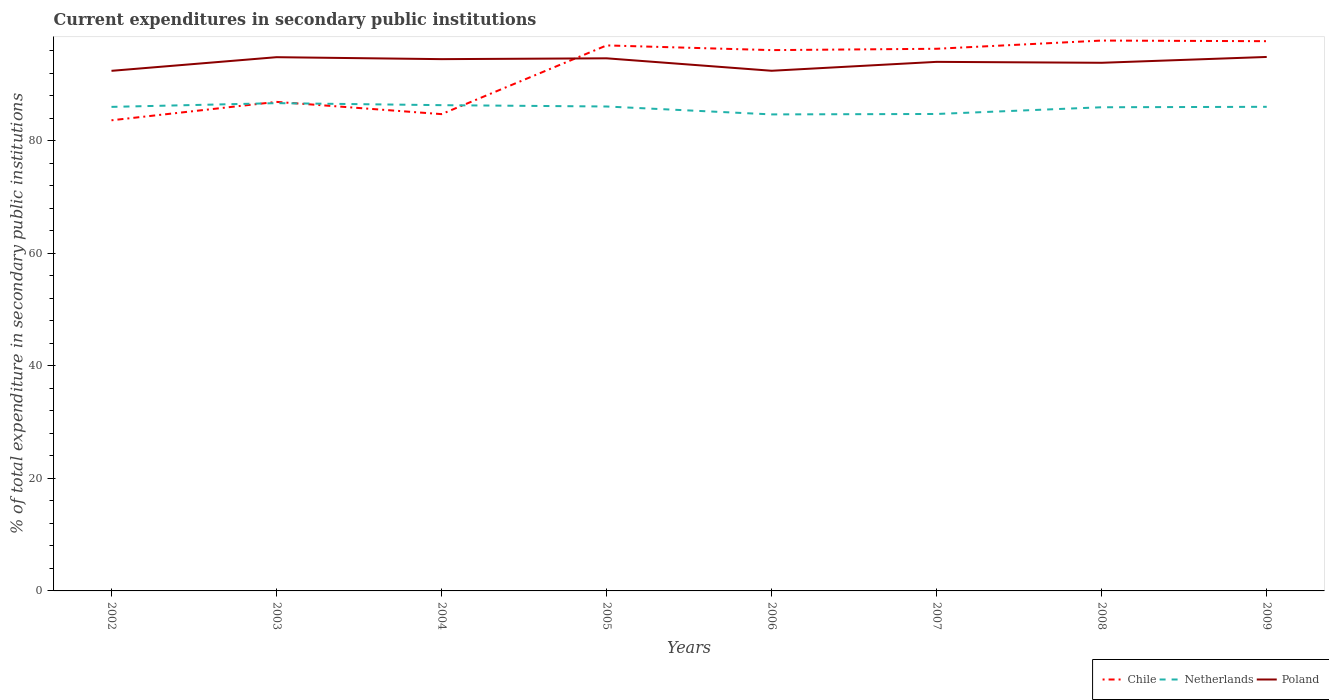Does the line corresponding to Poland intersect with the line corresponding to Chile?
Your response must be concise. Yes. Is the number of lines equal to the number of legend labels?
Your answer should be very brief. Yes. Across all years, what is the maximum current expenditures in secondary public institutions in Poland?
Provide a succinct answer. 92.39. In which year was the current expenditures in secondary public institutions in Poland maximum?
Provide a succinct answer. 2002. What is the total current expenditures in secondary public institutions in Netherlands in the graph?
Your answer should be very brief. -0.08. What is the difference between the highest and the second highest current expenditures in secondary public institutions in Chile?
Offer a terse response. 14.16. How many lines are there?
Offer a very short reply. 3. How many years are there in the graph?
Make the answer very short. 8. What is the difference between two consecutive major ticks on the Y-axis?
Your response must be concise. 20. Does the graph contain any zero values?
Keep it short and to the point. No. Does the graph contain grids?
Keep it short and to the point. No. Where does the legend appear in the graph?
Offer a terse response. Bottom right. How many legend labels are there?
Provide a short and direct response. 3. How are the legend labels stacked?
Ensure brevity in your answer.  Horizontal. What is the title of the graph?
Ensure brevity in your answer.  Current expenditures in secondary public institutions. What is the label or title of the X-axis?
Your answer should be compact. Years. What is the label or title of the Y-axis?
Make the answer very short. % of total expenditure in secondary public institutions. What is the % of total expenditure in secondary public institutions in Chile in 2002?
Ensure brevity in your answer.  83.6. What is the % of total expenditure in secondary public institutions in Netherlands in 2002?
Offer a terse response. 85.98. What is the % of total expenditure in secondary public institutions of Poland in 2002?
Offer a very short reply. 92.39. What is the % of total expenditure in secondary public institutions in Chile in 2003?
Provide a succinct answer. 86.87. What is the % of total expenditure in secondary public institutions of Netherlands in 2003?
Give a very brief answer. 86.65. What is the % of total expenditure in secondary public institutions of Poland in 2003?
Give a very brief answer. 94.81. What is the % of total expenditure in secondary public institutions in Chile in 2004?
Offer a terse response. 84.69. What is the % of total expenditure in secondary public institutions in Netherlands in 2004?
Your answer should be compact. 86.29. What is the % of total expenditure in secondary public institutions in Poland in 2004?
Give a very brief answer. 94.46. What is the % of total expenditure in secondary public institutions of Chile in 2005?
Your response must be concise. 96.9. What is the % of total expenditure in secondary public institutions in Netherlands in 2005?
Provide a succinct answer. 86.05. What is the % of total expenditure in secondary public institutions in Poland in 2005?
Give a very brief answer. 94.61. What is the % of total expenditure in secondary public institutions of Chile in 2006?
Make the answer very short. 96.07. What is the % of total expenditure in secondary public institutions in Netherlands in 2006?
Your response must be concise. 84.65. What is the % of total expenditure in secondary public institutions in Poland in 2006?
Your response must be concise. 92.4. What is the % of total expenditure in secondary public institutions in Chile in 2007?
Offer a very short reply. 96.31. What is the % of total expenditure in secondary public institutions of Netherlands in 2007?
Keep it short and to the point. 84.72. What is the % of total expenditure in secondary public institutions in Poland in 2007?
Your answer should be compact. 93.98. What is the % of total expenditure in secondary public institutions of Chile in 2008?
Ensure brevity in your answer.  97.76. What is the % of total expenditure in secondary public institutions of Netherlands in 2008?
Keep it short and to the point. 85.92. What is the % of total expenditure in secondary public institutions in Poland in 2008?
Make the answer very short. 93.82. What is the % of total expenditure in secondary public institutions in Chile in 2009?
Provide a succinct answer. 97.65. What is the % of total expenditure in secondary public institutions of Netherlands in 2009?
Offer a terse response. 86. What is the % of total expenditure in secondary public institutions of Poland in 2009?
Keep it short and to the point. 94.85. Across all years, what is the maximum % of total expenditure in secondary public institutions in Chile?
Give a very brief answer. 97.76. Across all years, what is the maximum % of total expenditure in secondary public institutions of Netherlands?
Offer a terse response. 86.65. Across all years, what is the maximum % of total expenditure in secondary public institutions of Poland?
Your response must be concise. 94.85. Across all years, what is the minimum % of total expenditure in secondary public institutions in Chile?
Make the answer very short. 83.6. Across all years, what is the minimum % of total expenditure in secondary public institutions of Netherlands?
Keep it short and to the point. 84.65. Across all years, what is the minimum % of total expenditure in secondary public institutions in Poland?
Your answer should be very brief. 92.39. What is the total % of total expenditure in secondary public institutions in Chile in the graph?
Your response must be concise. 739.85. What is the total % of total expenditure in secondary public institutions of Netherlands in the graph?
Offer a terse response. 686.24. What is the total % of total expenditure in secondary public institutions of Poland in the graph?
Give a very brief answer. 751.31. What is the difference between the % of total expenditure in secondary public institutions of Chile in 2002 and that in 2003?
Your response must be concise. -3.27. What is the difference between the % of total expenditure in secondary public institutions of Netherlands in 2002 and that in 2003?
Keep it short and to the point. -0.66. What is the difference between the % of total expenditure in secondary public institutions of Poland in 2002 and that in 2003?
Your response must be concise. -2.42. What is the difference between the % of total expenditure in secondary public institutions of Chile in 2002 and that in 2004?
Your answer should be compact. -1.09. What is the difference between the % of total expenditure in secondary public institutions of Netherlands in 2002 and that in 2004?
Give a very brief answer. -0.31. What is the difference between the % of total expenditure in secondary public institutions of Poland in 2002 and that in 2004?
Give a very brief answer. -2.08. What is the difference between the % of total expenditure in secondary public institutions of Chile in 2002 and that in 2005?
Provide a succinct answer. -13.3. What is the difference between the % of total expenditure in secondary public institutions in Netherlands in 2002 and that in 2005?
Offer a very short reply. -0.07. What is the difference between the % of total expenditure in secondary public institutions of Poland in 2002 and that in 2005?
Provide a succinct answer. -2.22. What is the difference between the % of total expenditure in secondary public institutions of Chile in 2002 and that in 2006?
Provide a succinct answer. -12.46. What is the difference between the % of total expenditure in secondary public institutions of Netherlands in 2002 and that in 2006?
Offer a very short reply. 1.34. What is the difference between the % of total expenditure in secondary public institutions of Poland in 2002 and that in 2006?
Offer a very short reply. -0.01. What is the difference between the % of total expenditure in secondary public institutions of Chile in 2002 and that in 2007?
Make the answer very short. -12.7. What is the difference between the % of total expenditure in secondary public institutions in Netherlands in 2002 and that in 2007?
Your response must be concise. 1.26. What is the difference between the % of total expenditure in secondary public institutions of Poland in 2002 and that in 2007?
Provide a succinct answer. -1.59. What is the difference between the % of total expenditure in secondary public institutions of Chile in 2002 and that in 2008?
Provide a succinct answer. -14.16. What is the difference between the % of total expenditure in secondary public institutions in Netherlands in 2002 and that in 2008?
Give a very brief answer. 0.07. What is the difference between the % of total expenditure in secondary public institutions in Poland in 2002 and that in 2008?
Provide a succinct answer. -1.43. What is the difference between the % of total expenditure in secondary public institutions of Chile in 2002 and that in 2009?
Your response must be concise. -14.05. What is the difference between the % of total expenditure in secondary public institutions of Netherlands in 2002 and that in 2009?
Offer a very short reply. -0.01. What is the difference between the % of total expenditure in secondary public institutions in Poland in 2002 and that in 2009?
Provide a succinct answer. -2.46. What is the difference between the % of total expenditure in secondary public institutions in Chile in 2003 and that in 2004?
Your answer should be compact. 2.17. What is the difference between the % of total expenditure in secondary public institutions in Netherlands in 2003 and that in 2004?
Keep it short and to the point. 0.36. What is the difference between the % of total expenditure in secondary public institutions in Poland in 2003 and that in 2004?
Make the answer very short. 0.35. What is the difference between the % of total expenditure in secondary public institutions in Chile in 2003 and that in 2005?
Make the answer very short. -10.03. What is the difference between the % of total expenditure in secondary public institutions in Netherlands in 2003 and that in 2005?
Your response must be concise. 0.6. What is the difference between the % of total expenditure in secondary public institutions in Poland in 2003 and that in 2005?
Offer a terse response. 0.2. What is the difference between the % of total expenditure in secondary public institutions in Chile in 2003 and that in 2006?
Offer a very short reply. -9.2. What is the difference between the % of total expenditure in secondary public institutions of Netherlands in 2003 and that in 2006?
Provide a succinct answer. 2. What is the difference between the % of total expenditure in secondary public institutions in Poland in 2003 and that in 2006?
Keep it short and to the point. 2.41. What is the difference between the % of total expenditure in secondary public institutions of Chile in 2003 and that in 2007?
Keep it short and to the point. -9.44. What is the difference between the % of total expenditure in secondary public institutions of Netherlands in 2003 and that in 2007?
Ensure brevity in your answer.  1.92. What is the difference between the % of total expenditure in secondary public institutions of Poland in 2003 and that in 2007?
Provide a short and direct response. 0.83. What is the difference between the % of total expenditure in secondary public institutions of Chile in 2003 and that in 2008?
Keep it short and to the point. -10.89. What is the difference between the % of total expenditure in secondary public institutions of Netherlands in 2003 and that in 2008?
Give a very brief answer. 0.73. What is the difference between the % of total expenditure in secondary public institutions of Chile in 2003 and that in 2009?
Keep it short and to the point. -10.78. What is the difference between the % of total expenditure in secondary public institutions in Netherlands in 2003 and that in 2009?
Your response must be concise. 0.65. What is the difference between the % of total expenditure in secondary public institutions of Poland in 2003 and that in 2009?
Offer a very short reply. -0.04. What is the difference between the % of total expenditure in secondary public institutions of Chile in 2004 and that in 2005?
Keep it short and to the point. -12.21. What is the difference between the % of total expenditure in secondary public institutions of Netherlands in 2004 and that in 2005?
Provide a short and direct response. 0.24. What is the difference between the % of total expenditure in secondary public institutions in Poland in 2004 and that in 2005?
Your answer should be very brief. -0.15. What is the difference between the % of total expenditure in secondary public institutions in Chile in 2004 and that in 2006?
Offer a very short reply. -11.37. What is the difference between the % of total expenditure in secondary public institutions in Netherlands in 2004 and that in 2006?
Give a very brief answer. 1.64. What is the difference between the % of total expenditure in secondary public institutions in Poland in 2004 and that in 2006?
Make the answer very short. 2.07. What is the difference between the % of total expenditure in secondary public institutions of Chile in 2004 and that in 2007?
Offer a terse response. -11.61. What is the difference between the % of total expenditure in secondary public institutions in Netherlands in 2004 and that in 2007?
Provide a short and direct response. 1.57. What is the difference between the % of total expenditure in secondary public institutions in Poland in 2004 and that in 2007?
Your answer should be very brief. 0.48. What is the difference between the % of total expenditure in secondary public institutions of Chile in 2004 and that in 2008?
Your response must be concise. -13.07. What is the difference between the % of total expenditure in secondary public institutions in Netherlands in 2004 and that in 2008?
Your response must be concise. 0.37. What is the difference between the % of total expenditure in secondary public institutions in Poland in 2004 and that in 2008?
Make the answer very short. 0.65. What is the difference between the % of total expenditure in secondary public institutions in Chile in 2004 and that in 2009?
Offer a very short reply. -12.96. What is the difference between the % of total expenditure in secondary public institutions in Netherlands in 2004 and that in 2009?
Provide a short and direct response. 0.29. What is the difference between the % of total expenditure in secondary public institutions in Poland in 2004 and that in 2009?
Your answer should be very brief. -0.39. What is the difference between the % of total expenditure in secondary public institutions of Chile in 2005 and that in 2006?
Make the answer very short. 0.84. What is the difference between the % of total expenditure in secondary public institutions of Netherlands in 2005 and that in 2006?
Make the answer very short. 1.4. What is the difference between the % of total expenditure in secondary public institutions in Poland in 2005 and that in 2006?
Your answer should be compact. 2.21. What is the difference between the % of total expenditure in secondary public institutions of Chile in 2005 and that in 2007?
Make the answer very short. 0.6. What is the difference between the % of total expenditure in secondary public institutions in Netherlands in 2005 and that in 2007?
Your response must be concise. 1.33. What is the difference between the % of total expenditure in secondary public institutions of Poland in 2005 and that in 2007?
Make the answer very short. 0.63. What is the difference between the % of total expenditure in secondary public institutions of Chile in 2005 and that in 2008?
Ensure brevity in your answer.  -0.86. What is the difference between the % of total expenditure in secondary public institutions in Netherlands in 2005 and that in 2008?
Your answer should be compact. 0.13. What is the difference between the % of total expenditure in secondary public institutions of Poland in 2005 and that in 2008?
Give a very brief answer. 0.79. What is the difference between the % of total expenditure in secondary public institutions in Chile in 2005 and that in 2009?
Make the answer very short. -0.75. What is the difference between the % of total expenditure in secondary public institutions of Netherlands in 2005 and that in 2009?
Provide a succinct answer. 0.05. What is the difference between the % of total expenditure in secondary public institutions in Poland in 2005 and that in 2009?
Provide a succinct answer. -0.24. What is the difference between the % of total expenditure in secondary public institutions in Chile in 2006 and that in 2007?
Give a very brief answer. -0.24. What is the difference between the % of total expenditure in secondary public institutions in Netherlands in 2006 and that in 2007?
Ensure brevity in your answer.  -0.08. What is the difference between the % of total expenditure in secondary public institutions in Poland in 2006 and that in 2007?
Your answer should be very brief. -1.58. What is the difference between the % of total expenditure in secondary public institutions in Chile in 2006 and that in 2008?
Your answer should be very brief. -1.7. What is the difference between the % of total expenditure in secondary public institutions in Netherlands in 2006 and that in 2008?
Keep it short and to the point. -1.27. What is the difference between the % of total expenditure in secondary public institutions in Poland in 2006 and that in 2008?
Provide a short and direct response. -1.42. What is the difference between the % of total expenditure in secondary public institutions in Chile in 2006 and that in 2009?
Provide a short and direct response. -1.59. What is the difference between the % of total expenditure in secondary public institutions of Netherlands in 2006 and that in 2009?
Provide a succinct answer. -1.35. What is the difference between the % of total expenditure in secondary public institutions in Poland in 2006 and that in 2009?
Give a very brief answer. -2.45. What is the difference between the % of total expenditure in secondary public institutions of Chile in 2007 and that in 2008?
Offer a very short reply. -1.46. What is the difference between the % of total expenditure in secondary public institutions in Netherlands in 2007 and that in 2008?
Keep it short and to the point. -1.19. What is the difference between the % of total expenditure in secondary public institutions of Poland in 2007 and that in 2008?
Keep it short and to the point. 0.17. What is the difference between the % of total expenditure in secondary public institutions in Chile in 2007 and that in 2009?
Ensure brevity in your answer.  -1.35. What is the difference between the % of total expenditure in secondary public institutions of Netherlands in 2007 and that in 2009?
Your answer should be compact. -1.27. What is the difference between the % of total expenditure in secondary public institutions of Poland in 2007 and that in 2009?
Your answer should be compact. -0.87. What is the difference between the % of total expenditure in secondary public institutions in Chile in 2008 and that in 2009?
Offer a terse response. 0.11. What is the difference between the % of total expenditure in secondary public institutions in Netherlands in 2008 and that in 2009?
Make the answer very short. -0.08. What is the difference between the % of total expenditure in secondary public institutions of Poland in 2008 and that in 2009?
Provide a succinct answer. -1.04. What is the difference between the % of total expenditure in secondary public institutions in Chile in 2002 and the % of total expenditure in secondary public institutions in Netherlands in 2003?
Give a very brief answer. -3.05. What is the difference between the % of total expenditure in secondary public institutions in Chile in 2002 and the % of total expenditure in secondary public institutions in Poland in 2003?
Keep it short and to the point. -11.21. What is the difference between the % of total expenditure in secondary public institutions of Netherlands in 2002 and the % of total expenditure in secondary public institutions of Poland in 2003?
Offer a very short reply. -8.83. What is the difference between the % of total expenditure in secondary public institutions of Chile in 2002 and the % of total expenditure in secondary public institutions of Netherlands in 2004?
Give a very brief answer. -2.69. What is the difference between the % of total expenditure in secondary public institutions of Chile in 2002 and the % of total expenditure in secondary public institutions of Poland in 2004?
Make the answer very short. -10.86. What is the difference between the % of total expenditure in secondary public institutions of Netherlands in 2002 and the % of total expenditure in secondary public institutions of Poland in 2004?
Make the answer very short. -8.48. What is the difference between the % of total expenditure in secondary public institutions in Chile in 2002 and the % of total expenditure in secondary public institutions in Netherlands in 2005?
Your response must be concise. -2.45. What is the difference between the % of total expenditure in secondary public institutions in Chile in 2002 and the % of total expenditure in secondary public institutions in Poland in 2005?
Your answer should be very brief. -11.01. What is the difference between the % of total expenditure in secondary public institutions in Netherlands in 2002 and the % of total expenditure in secondary public institutions in Poland in 2005?
Your response must be concise. -8.63. What is the difference between the % of total expenditure in secondary public institutions of Chile in 2002 and the % of total expenditure in secondary public institutions of Netherlands in 2006?
Give a very brief answer. -1.04. What is the difference between the % of total expenditure in secondary public institutions of Chile in 2002 and the % of total expenditure in secondary public institutions of Poland in 2006?
Offer a very short reply. -8.8. What is the difference between the % of total expenditure in secondary public institutions of Netherlands in 2002 and the % of total expenditure in secondary public institutions of Poland in 2006?
Your response must be concise. -6.41. What is the difference between the % of total expenditure in secondary public institutions in Chile in 2002 and the % of total expenditure in secondary public institutions in Netherlands in 2007?
Provide a short and direct response. -1.12. What is the difference between the % of total expenditure in secondary public institutions in Chile in 2002 and the % of total expenditure in secondary public institutions in Poland in 2007?
Your response must be concise. -10.38. What is the difference between the % of total expenditure in secondary public institutions of Netherlands in 2002 and the % of total expenditure in secondary public institutions of Poland in 2007?
Offer a very short reply. -8. What is the difference between the % of total expenditure in secondary public institutions in Chile in 2002 and the % of total expenditure in secondary public institutions in Netherlands in 2008?
Provide a succinct answer. -2.31. What is the difference between the % of total expenditure in secondary public institutions of Chile in 2002 and the % of total expenditure in secondary public institutions of Poland in 2008?
Keep it short and to the point. -10.21. What is the difference between the % of total expenditure in secondary public institutions of Netherlands in 2002 and the % of total expenditure in secondary public institutions of Poland in 2008?
Ensure brevity in your answer.  -7.83. What is the difference between the % of total expenditure in secondary public institutions of Chile in 2002 and the % of total expenditure in secondary public institutions of Netherlands in 2009?
Your answer should be very brief. -2.39. What is the difference between the % of total expenditure in secondary public institutions in Chile in 2002 and the % of total expenditure in secondary public institutions in Poland in 2009?
Offer a terse response. -11.25. What is the difference between the % of total expenditure in secondary public institutions in Netherlands in 2002 and the % of total expenditure in secondary public institutions in Poland in 2009?
Provide a succinct answer. -8.87. What is the difference between the % of total expenditure in secondary public institutions in Chile in 2003 and the % of total expenditure in secondary public institutions in Netherlands in 2004?
Provide a short and direct response. 0.58. What is the difference between the % of total expenditure in secondary public institutions in Chile in 2003 and the % of total expenditure in secondary public institutions in Poland in 2004?
Keep it short and to the point. -7.59. What is the difference between the % of total expenditure in secondary public institutions of Netherlands in 2003 and the % of total expenditure in secondary public institutions of Poland in 2004?
Your response must be concise. -7.82. What is the difference between the % of total expenditure in secondary public institutions of Chile in 2003 and the % of total expenditure in secondary public institutions of Netherlands in 2005?
Your answer should be very brief. 0.82. What is the difference between the % of total expenditure in secondary public institutions in Chile in 2003 and the % of total expenditure in secondary public institutions in Poland in 2005?
Give a very brief answer. -7.74. What is the difference between the % of total expenditure in secondary public institutions of Netherlands in 2003 and the % of total expenditure in secondary public institutions of Poland in 2005?
Provide a succinct answer. -7.96. What is the difference between the % of total expenditure in secondary public institutions in Chile in 2003 and the % of total expenditure in secondary public institutions in Netherlands in 2006?
Your response must be concise. 2.22. What is the difference between the % of total expenditure in secondary public institutions in Chile in 2003 and the % of total expenditure in secondary public institutions in Poland in 2006?
Provide a succinct answer. -5.53. What is the difference between the % of total expenditure in secondary public institutions of Netherlands in 2003 and the % of total expenditure in secondary public institutions of Poland in 2006?
Ensure brevity in your answer.  -5.75. What is the difference between the % of total expenditure in secondary public institutions of Chile in 2003 and the % of total expenditure in secondary public institutions of Netherlands in 2007?
Your response must be concise. 2.15. What is the difference between the % of total expenditure in secondary public institutions of Chile in 2003 and the % of total expenditure in secondary public institutions of Poland in 2007?
Provide a succinct answer. -7.11. What is the difference between the % of total expenditure in secondary public institutions in Netherlands in 2003 and the % of total expenditure in secondary public institutions in Poland in 2007?
Offer a very short reply. -7.33. What is the difference between the % of total expenditure in secondary public institutions of Chile in 2003 and the % of total expenditure in secondary public institutions of Netherlands in 2008?
Give a very brief answer. 0.95. What is the difference between the % of total expenditure in secondary public institutions in Chile in 2003 and the % of total expenditure in secondary public institutions in Poland in 2008?
Ensure brevity in your answer.  -6.95. What is the difference between the % of total expenditure in secondary public institutions of Netherlands in 2003 and the % of total expenditure in secondary public institutions of Poland in 2008?
Ensure brevity in your answer.  -7.17. What is the difference between the % of total expenditure in secondary public institutions in Chile in 2003 and the % of total expenditure in secondary public institutions in Netherlands in 2009?
Offer a terse response. 0.87. What is the difference between the % of total expenditure in secondary public institutions of Chile in 2003 and the % of total expenditure in secondary public institutions of Poland in 2009?
Your response must be concise. -7.98. What is the difference between the % of total expenditure in secondary public institutions of Netherlands in 2003 and the % of total expenditure in secondary public institutions of Poland in 2009?
Provide a succinct answer. -8.2. What is the difference between the % of total expenditure in secondary public institutions of Chile in 2004 and the % of total expenditure in secondary public institutions of Netherlands in 2005?
Your response must be concise. -1.35. What is the difference between the % of total expenditure in secondary public institutions in Chile in 2004 and the % of total expenditure in secondary public institutions in Poland in 2005?
Your answer should be compact. -9.91. What is the difference between the % of total expenditure in secondary public institutions of Netherlands in 2004 and the % of total expenditure in secondary public institutions of Poland in 2005?
Give a very brief answer. -8.32. What is the difference between the % of total expenditure in secondary public institutions of Chile in 2004 and the % of total expenditure in secondary public institutions of Netherlands in 2006?
Offer a very short reply. 0.05. What is the difference between the % of total expenditure in secondary public institutions of Chile in 2004 and the % of total expenditure in secondary public institutions of Poland in 2006?
Offer a terse response. -7.7. What is the difference between the % of total expenditure in secondary public institutions in Netherlands in 2004 and the % of total expenditure in secondary public institutions in Poland in 2006?
Keep it short and to the point. -6.11. What is the difference between the % of total expenditure in secondary public institutions of Chile in 2004 and the % of total expenditure in secondary public institutions of Netherlands in 2007?
Provide a succinct answer. -0.03. What is the difference between the % of total expenditure in secondary public institutions of Chile in 2004 and the % of total expenditure in secondary public institutions of Poland in 2007?
Offer a very short reply. -9.29. What is the difference between the % of total expenditure in secondary public institutions of Netherlands in 2004 and the % of total expenditure in secondary public institutions of Poland in 2007?
Your response must be concise. -7.69. What is the difference between the % of total expenditure in secondary public institutions in Chile in 2004 and the % of total expenditure in secondary public institutions in Netherlands in 2008?
Keep it short and to the point. -1.22. What is the difference between the % of total expenditure in secondary public institutions of Chile in 2004 and the % of total expenditure in secondary public institutions of Poland in 2008?
Give a very brief answer. -9.12. What is the difference between the % of total expenditure in secondary public institutions of Netherlands in 2004 and the % of total expenditure in secondary public institutions of Poland in 2008?
Offer a terse response. -7.53. What is the difference between the % of total expenditure in secondary public institutions of Chile in 2004 and the % of total expenditure in secondary public institutions of Netherlands in 2009?
Offer a very short reply. -1.3. What is the difference between the % of total expenditure in secondary public institutions of Chile in 2004 and the % of total expenditure in secondary public institutions of Poland in 2009?
Offer a very short reply. -10.16. What is the difference between the % of total expenditure in secondary public institutions in Netherlands in 2004 and the % of total expenditure in secondary public institutions in Poland in 2009?
Provide a short and direct response. -8.56. What is the difference between the % of total expenditure in secondary public institutions in Chile in 2005 and the % of total expenditure in secondary public institutions in Netherlands in 2006?
Provide a short and direct response. 12.26. What is the difference between the % of total expenditure in secondary public institutions in Chile in 2005 and the % of total expenditure in secondary public institutions in Poland in 2006?
Offer a very short reply. 4.5. What is the difference between the % of total expenditure in secondary public institutions of Netherlands in 2005 and the % of total expenditure in secondary public institutions of Poland in 2006?
Your answer should be very brief. -6.35. What is the difference between the % of total expenditure in secondary public institutions of Chile in 2005 and the % of total expenditure in secondary public institutions of Netherlands in 2007?
Provide a short and direct response. 12.18. What is the difference between the % of total expenditure in secondary public institutions in Chile in 2005 and the % of total expenditure in secondary public institutions in Poland in 2007?
Give a very brief answer. 2.92. What is the difference between the % of total expenditure in secondary public institutions of Netherlands in 2005 and the % of total expenditure in secondary public institutions of Poland in 2007?
Your response must be concise. -7.93. What is the difference between the % of total expenditure in secondary public institutions in Chile in 2005 and the % of total expenditure in secondary public institutions in Netherlands in 2008?
Give a very brief answer. 10.99. What is the difference between the % of total expenditure in secondary public institutions in Chile in 2005 and the % of total expenditure in secondary public institutions in Poland in 2008?
Offer a very short reply. 3.09. What is the difference between the % of total expenditure in secondary public institutions in Netherlands in 2005 and the % of total expenditure in secondary public institutions in Poland in 2008?
Provide a short and direct response. -7.77. What is the difference between the % of total expenditure in secondary public institutions in Chile in 2005 and the % of total expenditure in secondary public institutions in Netherlands in 2009?
Provide a short and direct response. 10.91. What is the difference between the % of total expenditure in secondary public institutions of Chile in 2005 and the % of total expenditure in secondary public institutions of Poland in 2009?
Provide a short and direct response. 2.05. What is the difference between the % of total expenditure in secondary public institutions in Netherlands in 2005 and the % of total expenditure in secondary public institutions in Poland in 2009?
Your answer should be very brief. -8.8. What is the difference between the % of total expenditure in secondary public institutions of Chile in 2006 and the % of total expenditure in secondary public institutions of Netherlands in 2007?
Offer a terse response. 11.34. What is the difference between the % of total expenditure in secondary public institutions of Chile in 2006 and the % of total expenditure in secondary public institutions of Poland in 2007?
Offer a terse response. 2.08. What is the difference between the % of total expenditure in secondary public institutions in Netherlands in 2006 and the % of total expenditure in secondary public institutions in Poland in 2007?
Keep it short and to the point. -9.34. What is the difference between the % of total expenditure in secondary public institutions of Chile in 2006 and the % of total expenditure in secondary public institutions of Netherlands in 2008?
Offer a very short reply. 10.15. What is the difference between the % of total expenditure in secondary public institutions in Chile in 2006 and the % of total expenditure in secondary public institutions in Poland in 2008?
Provide a succinct answer. 2.25. What is the difference between the % of total expenditure in secondary public institutions in Netherlands in 2006 and the % of total expenditure in secondary public institutions in Poland in 2008?
Make the answer very short. -9.17. What is the difference between the % of total expenditure in secondary public institutions in Chile in 2006 and the % of total expenditure in secondary public institutions in Netherlands in 2009?
Make the answer very short. 10.07. What is the difference between the % of total expenditure in secondary public institutions of Chile in 2006 and the % of total expenditure in secondary public institutions of Poland in 2009?
Offer a terse response. 1.21. What is the difference between the % of total expenditure in secondary public institutions in Netherlands in 2006 and the % of total expenditure in secondary public institutions in Poland in 2009?
Keep it short and to the point. -10.21. What is the difference between the % of total expenditure in secondary public institutions of Chile in 2007 and the % of total expenditure in secondary public institutions of Netherlands in 2008?
Give a very brief answer. 10.39. What is the difference between the % of total expenditure in secondary public institutions in Chile in 2007 and the % of total expenditure in secondary public institutions in Poland in 2008?
Ensure brevity in your answer.  2.49. What is the difference between the % of total expenditure in secondary public institutions of Netherlands in 2007 and the % of total expenditure in secondary public institutions of Poland in 2008?
Your answer should be very brief. -9.09. What is the difference between the % of total expenditure in secondary public institutions of Chile in 2007 and the % of total expenditure in secondary public institutions of Netherlands in 2009?
Offer a very short reply. 10.31. What is the difference between the % of total expenditure in secondary public institutions in Chile in 2007 and the % of total expenditure in secondary public institutions in Poland in 2009?
Give a very brief answer. 1.45. What is the difference between the % of total expenditure in secondary public institutions in Netherlands in 2007 and the % of total expenditure in secondary public institutions in Poland in 2009?
Provide a short and direct response. -10.13. What is the difference between the % of total expenditure in secondary public institutions in Chile in 2008 and the % of total expenditure in secondary public institutions in Netherlands in 2009?
Offer a terse response. 11.77. What is the difference between the % of total expenditure in secondary public institutions of Chile in 2008 and the % of total expenditure in secondary public institutions of Poland in 2009?
Provide a succinct answer. 2.91. What is the difference between the % of total expenditure in secondary public institutions in Netherlands in 2008 and the % of total expenditure in secondary public institutions in Poland in 2009?
Provide a short and direct response. -8.94. What is the average % of total expenditure in secondary public institutions in Chile per year?
Ensure brevity in your answer.  92.48. What is the average % of total expenditure in secondary public institutions of Netherlands per year?
Ensure brevity in your answer.  85.78. What is the average % of total expenditure in secondary public institutions of Poland per year?
Offer a very short reply. 93.91. In the year 2002, what is the difference between the % of total expenditure in secondary public institutions of Chile and % of total expenditure in secondary public institutions of Netherlands?
Your answer should be very brief. -2.38. In the year 2002, what is the difference between the % of total expenditure in secondary public institutions of Chile and % of total expenditure in secondary public institutions of Poland?
Give a very brief answer. -8.79. In the year 2002, what is the difference between the % of total expenditure in secondary public institutions of Netherlands and % of total expenditure in secondary public institutions of Poland?
Provide a short and direct response. -6.4. In the year 2003, what is the difference between the % of total expenditure in secondary public institutions in Chile and % of total expenditure in secondary public institutions in Netherlands?
Keep it short and to the point. 0.22. In the year 2003, what is the difference between the % of total expenditure in secondary public institutions of Chile and % of total expenditure in secondary public institutions of Poland?
Provide a succinct answer. -7.94. In the year 2003, what is the difference between the % of total expenditure in secondary public institutions of Netherlands and % of total expenditure in secondary public institutions of Poland?
Your answer should be compact. -8.16. In the year 2004, what is the difference between the % of total expenditure in secondary public institutions of Chile and % of total expenditure in secondary public institutions of Netherlands?
Offer a terse response. -1.59. In the year 2004, what is the difference between the % of total expenditure in secondary public institutions in Chile and % of total expenditure in secondary public institutions in Poland?
Your answer should be very brief. -9.77. In the year 2004, what is the difference between the % of total expenditure in secondary public institutions of Netherlands and % of total expenditure in secondary public institutions of Poland?
Keep it short and to the point. -8.17. In the year 2005, what is the difference between the % of total expenditure in secondary public institutions of Chile and % of total expenditure in secondary public institutions of Netherlands?
Give a very brief answer. 10.85. In the year 2005, what is the difference between the % of total expenditure in secondary public institutions of Chile and % of total expenditure in secondary public institutions of Poland?
Your answer should be very brief. 2.29. In the year 2005, what is the difference between the % of total expenditure in secondary public institutions of Netherlands and % of total expenditure in secondary public institutions of Poland?
Make the answer very short. -8.56. In the year 2006, what is the difference between the % of total expenditure in secondary public institutions of Chile and % of total expenditure in secondary public institutions of Netherlands?
Provide a short and direct response. 11.42. In the year 2006, what is the difference between the % of total expenditure in secondary public institutions of Chile and % of total expenditure in secondary public institutions of Poland?
Offer a terse response. 3.67. In the year 2006, what is the difference between the % of total expenditure in secondary public institutions in Netherlands and % of total expenditure in secondary public institutions in Poland?
Offer a very short reply. -7.75. In the year 2007, what is the difference between the % of total expenditure in secondary public institutions in Chile and % of total expenditure in secondary public institutions in Netherlands?
Offer a very short reply. 11.58. In the year 2007, what is the difference between the % of total expenditure in secondary public institutions of Chile and % of total expenditure in secondary public institutions of Poland?
Your answer should be compact. 2.32. In the year 2007, what is the difference between the % of total expenditure in secondary public institutions of Netherlands and % of total expenditure in secondary public institutions of Poland?
Give a very brief answer. -9.26. In the year 2008, what is the difference between the % of total expenditure in secondary public institutions in Chile and % of total expenditure in secondary public institutions in Netherlands?
Provide a short and direct response. 11.85. In the year 2008, what is the difference between the % of total expenditure in secondary public institutions in Chile and % of total expenditure in secondary public institutions in Poland?
Offer a very short reply. 3.95. In the year 2008, what is the difference between the % of total expenditure in secondary public institutions of Netherlands and % of total expenditure in secondary public institutions of Poland?
Provide a short and direct response. -7.9. In the year 2009, what is the difference between the % of total expenditure in secondary public institutions in Chile and % of total expenditure in secondary public institutions in Netherlands?
Ensure brevity in your answer.  11.66. In the year 2009, what is the difference between the % of total expenditure in secondary public institutions of Chile and % of total expenditure in secondary public institutions of Poland?
Offer a terse response. 2.8. In the year 2009, what is the difference between the % of total expenditure in secondary public institutions in Netherlands and % of total expenditure in secondary public institutions in Poland?
Offer a terse response. -8.86. What is the ratio of the % of total expenditure in secondary public institutions of Chile in 2002 to that in 2003?
Offer a terse response. 0.96. What is the ratio of the % of total expenditure in secondary public institutions of Poland in 2002 to that in 2003?
Provide a short and direct response. 0.97. What is the ratio of the % of total expenditure in secondary public institutions in Chile in 2002 to that in 2004?
Your answer should be compact. 0.99. What is the ratio of the % of total expenditure in secondary public institutions in Netherlands in 2002 to that in 2004?
Your answer should be compact. 1. What is the ratio of the % of total expenditure in secondary public institutions in Chile in 2002 to that in 2005?
Your answer should be very brief. 0.86. What is the ratio of the % of total expenditure in secondary public institutions of Poland in 2002 to that in 2005?
Give a very brief answer. 0.98. What is the ratio of the % of total expenditure in secondary public institutions in Chile in 2002 to that in 2006?
Make the answer very short. 0.87. What is the ratio of the % of total expenditure in secondary public institutions in Netherlands in 2002 to that in 2006?
Your answer should be very brief. 1.02. What is the ratio of the % of total expenditure in secondary public institutions of Poland in 2002 to that in 2006?
Keep it short and to the point. 1. What is the ratio of the % of total expenditure in secondary public institutions of Chile in 2002 to that in 2007?
Your answer should be very brief. 0.87. What is the ratio of the % of total expenditure in secondary public institutions of Netherlands in 2002 to that in 2007?
Keep it short and to the point. 1.01. What is the ratio of the % of total expenditure in secondary public institutions of Poland in 2002 to that in 2007?
Make the answer very short. 0.98. What is the ratio of the % of total expenditure in secondary public institutions of Chile in 2002 to that in 2008?
Make the answer very short. 0.86. What is the ratio of the % of total expenditure in secondary public institutions in Netherlands in 2002 to that in 2008?
Offer a very short reply. 1. What is the ratio of the % of total expenditure in secondary public institutions in Chile in 2002 to that in 2009?
Give a very brief answer. 0.86. What is the ratio of the % of total expenditure in secondary public institutions of Chile in 2003 to that in 2004?
Offer a very short reply. 1.03. What is the ratio of the % of total expenditure in secondary public institutions of Netherlands in 2003 to that in 2004?
Keep it short and to the point. 1. What is the ratio of the % of total expenditure in secondary public institutions of Poland in 2003 to that in 2004?
Make the answer very short. 1. What is the ratio of the % of total expenditure in secondary public institutions of Chile in 2003 to that in 2005?
Keep it short and to the point. 0.9. What is the ratio of the % of total expenditure in secondary public institutions in Netherlands in 2003 to that in 2005?
Ensure brevity in your answer.  1.01. What is the ratio of the % of total expenditure in secondary public institutions in Poland in 2003 to that in 2005?
Provide a short and direct response. 1. What is the ratio of the % of total expenditure in secondary public institutions in Chile in 2003 to that in 2006?
Give a very brief answer. 0.9. What is the ratio of the % of total expenditure in secondary public institutions in Netherlands in 2003 to that in 2006?
Give a very brief answer. 1.02. What is the ratio of the % of total expenditure in secondary public institutions in Poland in 2003 to that in 2006?
Offer a terse response. 1.03. What is the ratio of the % of total expenditure in secondary public institutions in Chile in 2003 to that in 2007?
Provide a short and direct response. 0.9. What is the ratio of the % of total expenditure in secondary public institutions in Netherlands in 2003 to that in 2007?
Your answer should be compact. 1.02. What is the ratio of the % of total expenditure in secondary public institutions in Poland in 2003 to that in 2007?
Offer a very short reply. 1.01. What is the ratio of the % of total expenditure in secondary public institutions in Chile in 2003 to that in 2008?
Make the answer very short. 0.89. What is the ratio of the % of total expenditure in secondary public institutions in Netherlands in 2003 to that in 2008?
Offer a terse response. 1.01. What is the ratio of the % of total expenditure in secondary public institutions in Poland in 2003 to that in 2008?
Your answer should be compact. 1.01. What is the ratio of the % of total expenditure in secondary public institutions in Chile in 2003 to that in 2009?
Give a very brief answer. 0.89. What is the ratio of the % of total expenditure in secondary public institutions in Netherlands in 2003 to that in 2009?
Provide a succinct answer. 1.01. What is the ratio of the % of total expenditure in secondary public institutions of Poland in 2003 to that in 2009?
Your answer should be compact. 1. What is the ratio of the % of total expenditure in secondary public institutions in Chile in 2004 to that in 2005?
Give a very brief answer. 0.87. What is the ratio of the % of total expenditure in secondary public institutions in Netherlands in 2004 to that in 2005?
Provide a succinct answer. 1. What is the ratio of the % of total expenditure in secondary public institutions of Poland in 2004 to that in 2005?
Offer a very short reply. 1. What is the ratio of the % of total expenditure in secondary public institutions of Chile in 2004 to that in 2006?
Your answer should be very brief. 0.88. What is the ratio of the % of total expenditure in secondary public institutions of Netherlands in 2004 to that in 2006?
Offer a terse response. 1.02. What is the ratio of the % of total expenditure in secondary public institutions in Poland in 2004 to that in 2006?
Provide a succinct answer. 1.02. What is the ratio of the % of total expenditure in secondary public institutions of Chile in 2004 to that in 2007?
Your answer should be very brief. 0.88. What is the ratio of the % of total expenditure in secondary public institutions of Netherlands in 2004 to that in 2007?
Offer a very short reply. 1.02. What is the ratio of the % of total expenditure in secondary public institutions in Poland in 2004 to that in 2007?
Offer a terse response. 1.01. What is the ratio of the % of total expenditure in secondary public institutions of Chile in 2004 to that in 2008?
Offer a terse response. 0.87. What is the ratio of the % of total expenditure in secondary public institutions of Poland in 2004 to that in 2008?
Your answer should be compact. 1.01. What is the ratio of the % of total expenditure in secondary public institutions of Chile in 2004 to that in 2009?
Your response must be concise. 0.87. What is the ratio of the % of total expenditure in secondary public institutions in Netherlands in 2004 to that in 2009?
Make the answer very short. 1. What is the ratio of the % of total expenditure in secondary public institutions in Chile in 2005 to that in 2006?
Your response must be concise. 1.01. What is the ratio of the % of total expenditure in secondary public institutions of Netherlands in 2005 to that in 2006?
Offer a very short reply. 1.02. What is the ratio of the % of total expenditure in secondary public institutions of Poland in 2005 to that in 2006?
Your answer should be very brief. 1.02. What is the ratio of the % of total expenditure in secondary public institutions in Chile in 2005 to that in 2007?
Your answer should be very brief. 1.01. What is the ratio of the % of total expenditure in secondary public institutions in Netherlands in 2005 to that in 2007?
Offer a very short reply. 1.02. What is the ratio of the % of total expenditure in secondary public institutions in Poland in 2005 to that in 2007?
Your answer should be very brief. 1.01. What is the ratio of the % of total expenditure in secondary public institutions in Chile in 2005 to that in 2008?
Provide a succinct answer. 0.99. What is the ratio of the % of total expenditure in secondary public institutions in Netherlands in 2005 to that in 2008?
Provide a short and direct response. 1. What is the ratio of the % of total expenditure in secondary public institutions of Poland in 2005 to that in 2008?
Ensure brevity in your answer.  1.01. What is the ratio of the % of total expenditure in secondary public institutions of Chile in 2006 to that in 2007?
Provide a short and direct response. 1. What is the ratio of the % of total expenditure in secondary public institutions of Netherlands in 2006 to that in 2007?
Offer a very short reply. 1. What is the ratio of the % of total expenditure in secondary public institutions in Poland in 2006 to that in 2007?
Keep it short and to the point. 0.98. What is the ratio of the % of total expenditure in secondary public institutions of Chile in 2006 to that in 2008?
Keep it short and to the point. 0.98. What is the ratio of the % of total expenditure in secondary public institutions in Netherlands in 2006 to that in 2008?
Make the answer very short. 0.99. What is the ratio of the % of total expenditure in secondary public institutions of Poland in 2006 to that in 2008?
Keep it short and to the point. 0.98. What is the ratio of the % of total expenditure in secondary public institutions in Chile in 2006 to that in 2009?
Give a very brief answer. 0.98. What is the ratio of the % of total expenditure in secondary public institutions of Netherlands in 2006 to that in 2009?
Offer a terse response. 0.98. What is the ratio of the % of total expenditure in secondary public institutions of Poland in 2006 to that in 2009?
Ensure brevity in your answer.  0.97. What is the ratio of the % of total expenditure in secondary public institutions of Chile in 2007 to that in 2008?
Your answer should be compact. 0.99. What is the ratio of the % of total expenditure in secondary public institutions in Netherlands in 2007 to that in 2008?
Ensure brevity in your answer.  0.99. What is the ratio of the % of total expenditure in secondary public institutions in Poland in 2007 to that in 2008?
Offer a terse response. 1. What is the ratio of the % of total expenditure in secondary public institutions in Chile in 2007 to that in 2009?
Offer a terse response. 0.99. What is the ratio of the % of total expenditure in secondary public institutions of Netherlands in 2007 to that in 2009?
Provide a succinct answer. 0.99. What is the ratio of the % of total expenditure in secondary public institutions of Chile in 2008 to that in 2009?
Offer a terse response. 1. What is the ratio of the % of total expenditure in secondary public institutions in Netherlands in 2008 to that in 2009?
Your answer should be compact. 1. What is the difference between the highest and the second highest % of total expenditure in secondary public institutions of Chile?
Make the answer very short. 0.11. What is the difference between the highest and the second highest % of total expenditure in secondary public institutions in Netherlands?
Make the answer very short. 0.36. What is the difference between the highest and the second highest % of total expenditure in secondary public institutions in Poland?
Your answer should be compact. 0.04. What is the difference between the highest and the lowest % of total expenditure in secondary public institutions in Chile?
Your answer should be compact. 14.16. What is the difference between the highest and the lowest % of total expenditure in secondary public institutions of Netherlands?
Ensure brevity in your answer.  2. What is the difference between the highest and the lowest % of total expenditure in secondary public institutions in Poland?
Make the answer very short. 2.46. 